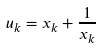<formula> <loc_0><loc_0><loc_500><loc_500>u _ { k } = x _ { k } + \frac { 1 } { x _ { k } }</formula> 